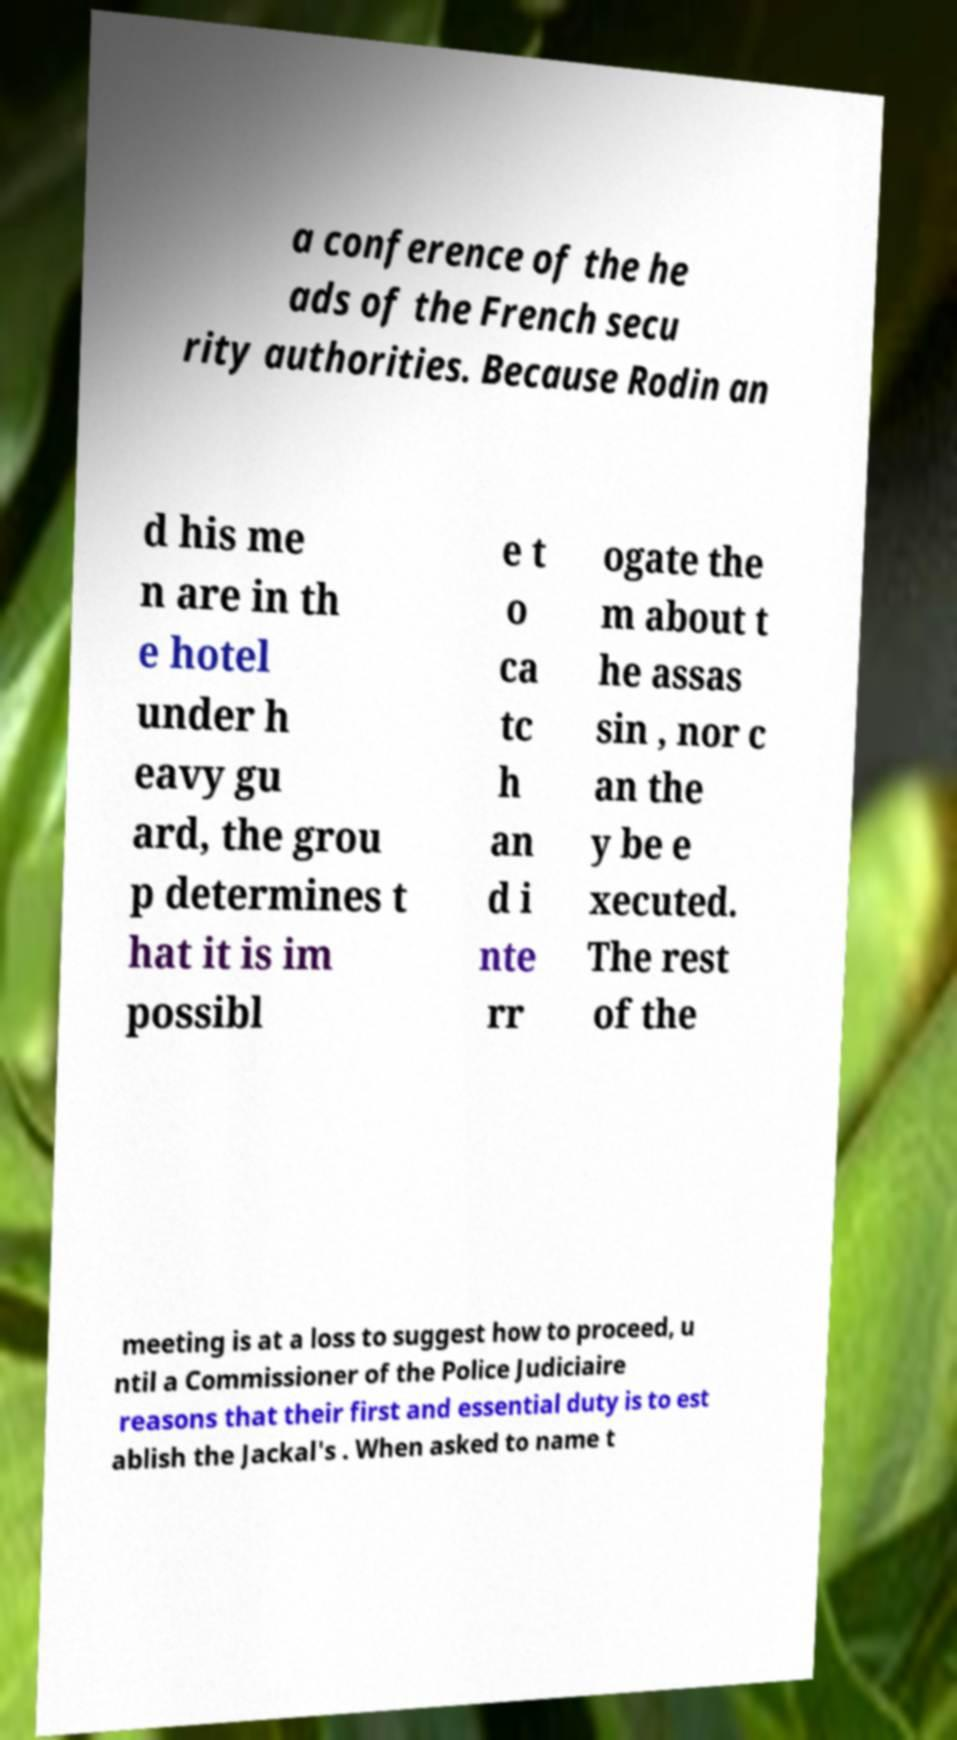Can you read and provide the text displayed in the image?This photo seems to have some interesting text. Can you extract and type it out for me? a conference of the he ads of the French secu rity authorities. Because Rodin an d his me n are in th e hotel under h eavy gu ard, the grou p determines t hat it is im possibl e t o ca tc h an d i nte rr ogate the m about t he assas sin , nor c an the y be e xecuted. The rest of the meeting is at a loss to suggest how to proceed, u ntil a Commissioner of the Police Judiciaire reasons that their first and essential duty is to est ablish the Jackal's . When asked to name t 